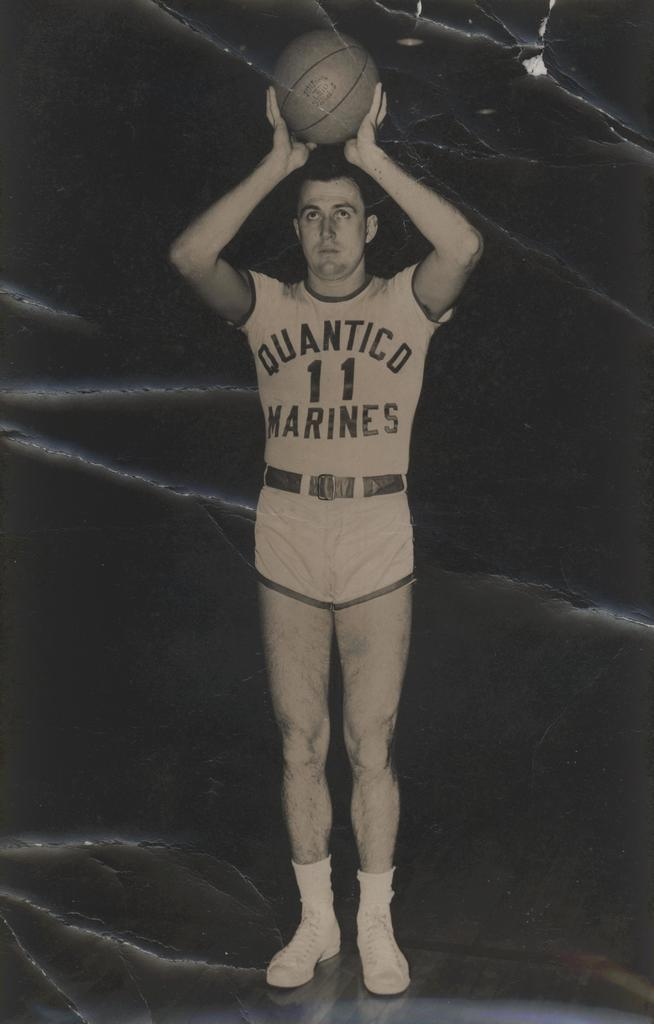<image>
Create a compact narrative representing the image presented. A man wearing short shorts and a Quantico 11 marines t-shirt is throwing a basketball. 